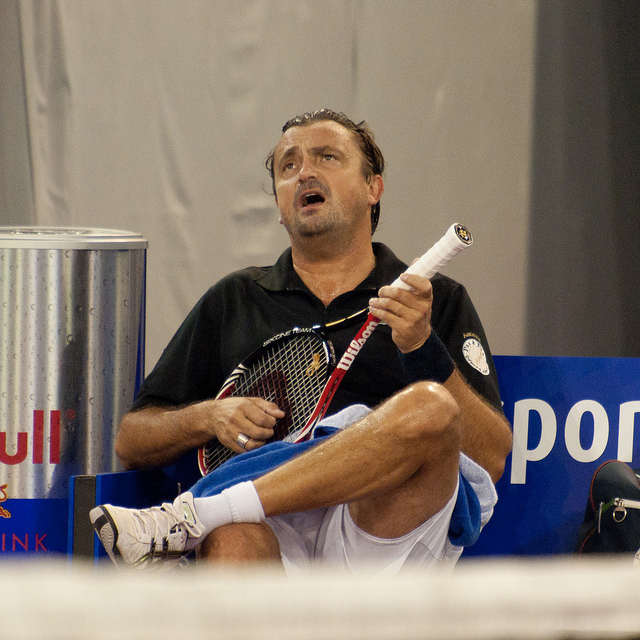Extract all visible text content from this image. po ull INK Wilson 